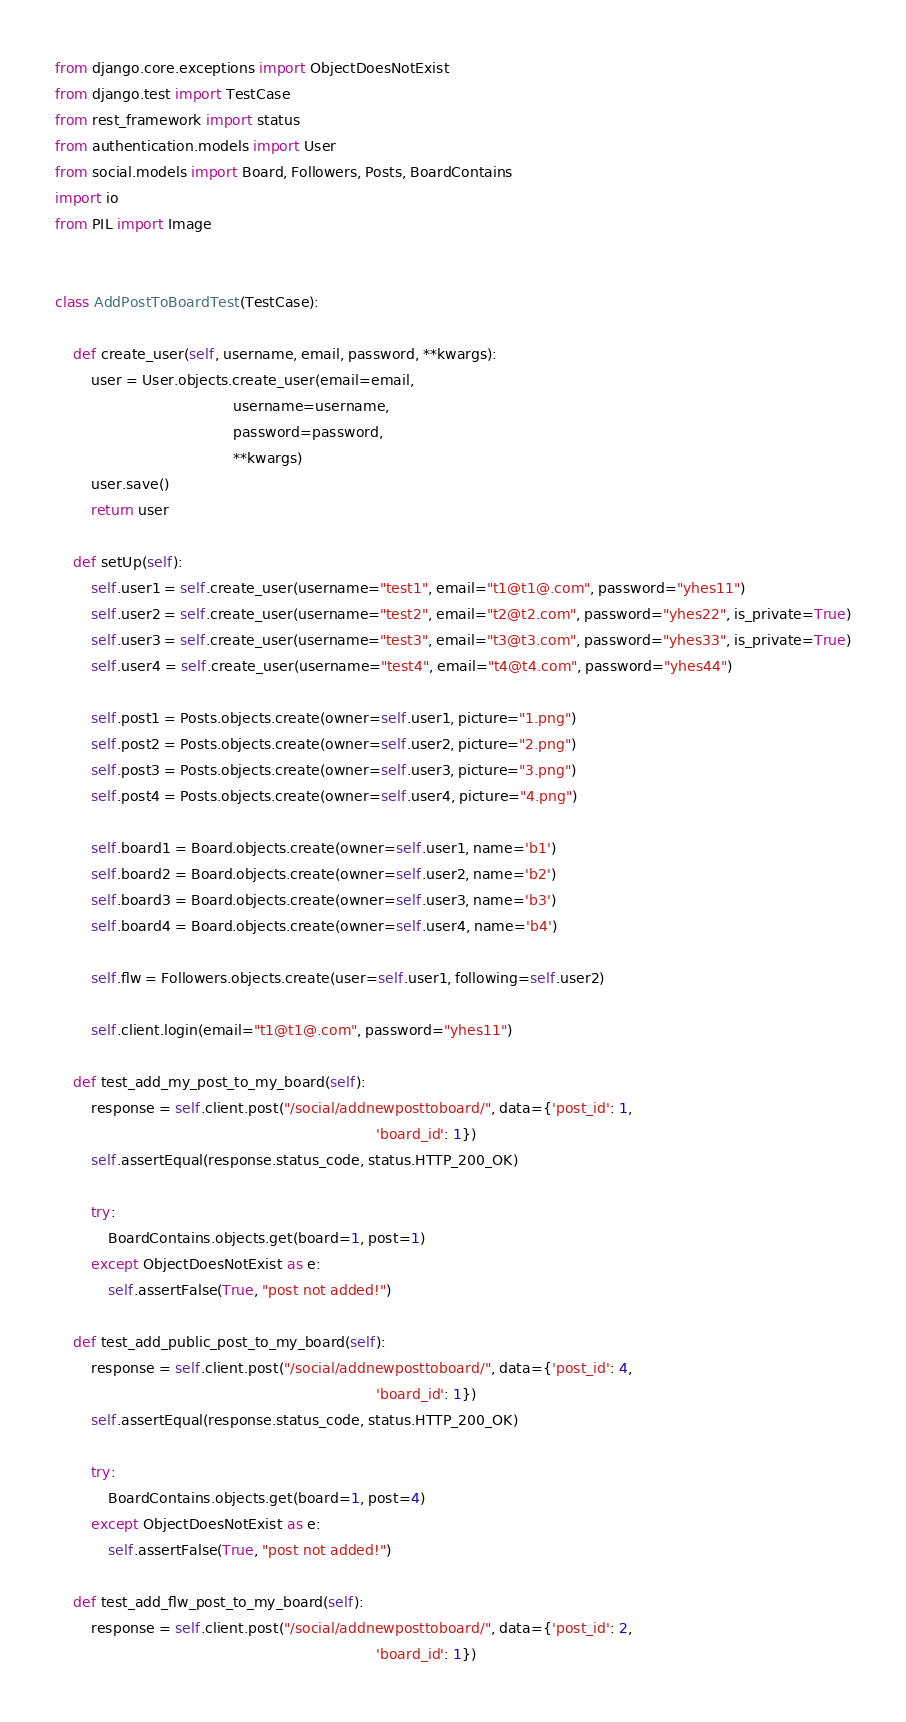Convert code to text. <code><loc_0><loc_0><loc_500><loc_500><_Python_>from django.core.exceptions import ObjectDoesNotExist
from django.test import TestCase
from rest_framework import status
from authentication.models import User
from social.models import Board, Followers, Posts, BoardContains
import io
from PIL import Image


class AddPostToBoardTest(TestCase):

    def create_user(self, username, email, password, **kwargs):
        user = User.objects.create_user(email=email,
                                        username=username,
                                        password=password,
                                        **kwargs)
        user.save()
        return user

    def setUp(self):
        self.user1 = self.create_user(username="test1", email="t1@t1@.com", password="yhes11")
        self.user2 = self.create_user(username="test2", email="t2@t2.com", password="yhes22", is_private=True)
        self.user3 = self.create_user(username="test3", email="t3@t3.com", password="yhes33", is_private=True)
        self.user4 = self.create_user(username="test4", email="t4@t4.com", password="yhes44")

        self.post1 = Posts.objects.create(owner=self.user1, picture="1.png")
        self.post2 = Posts.objects.create(owner=self.user2, picture="2.png")
        self.post3 = Posts.objects.create(owner=self.user3, picture="3.png")
        self.post4 = Posts.objects.create(owner=self.user4, picture="4.png")

        self.board1 = Board.objects.create(owner=self.user1, name='b1')
        self.board2 = Board.objects.create(owner=self.user2, name='b2')
        self.board3 = Board.objects.create(owner=self.user3, name='b3')
        self.board4 = Board.objects.create(owner=self.user4, name='b4')

        self.flw = Followers.objects.create(user=self.user1, following=self.user2)

        self.client.login(email="t1@t1@.com", password="yhes11")

    def test_add_my_post_to_my_board(self):
        response = self.client.post("/social/addnewposttoboard/", data={'post_id': 1,
                                                                        'board_id': 1})
        self.assertEqual(response.status_code, status.HTTP_200_OK)

        try:
            BoardContains.objects.get(board=1, post=1)
        except ObjectDoesNotExist as e:
            self.assertFalse(True, "post not added!")

    def test_add_public_post_to_my_board(self):
        response = self.client.post("/social/addnewposttoboard/", data={'post_id': 4,
                                                                        'board_id': 1})
        self.assertEqual(response.status_code, status.HTTP_200_OK)

        try:
            BoardContains.objects.get(board=1, post=4)
        except ObjectDoesNotExist as e:
            self.assertFalse(True, "post not added!")

    def test_add_flw_post_to_my_board(self):
        response = self.client.post("/social/addnewposttoboard/", data={'post_id': 2,
                                                                        'board_id': 1})</code> 